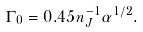<formula> <loc_0><loc_0><loc_500><loc_500>\Gamma _ { 0 } = 0 . 4 5 n _ { J } ^ { - 1 } \alpha ^ { 1 / 2 } .</formula> 